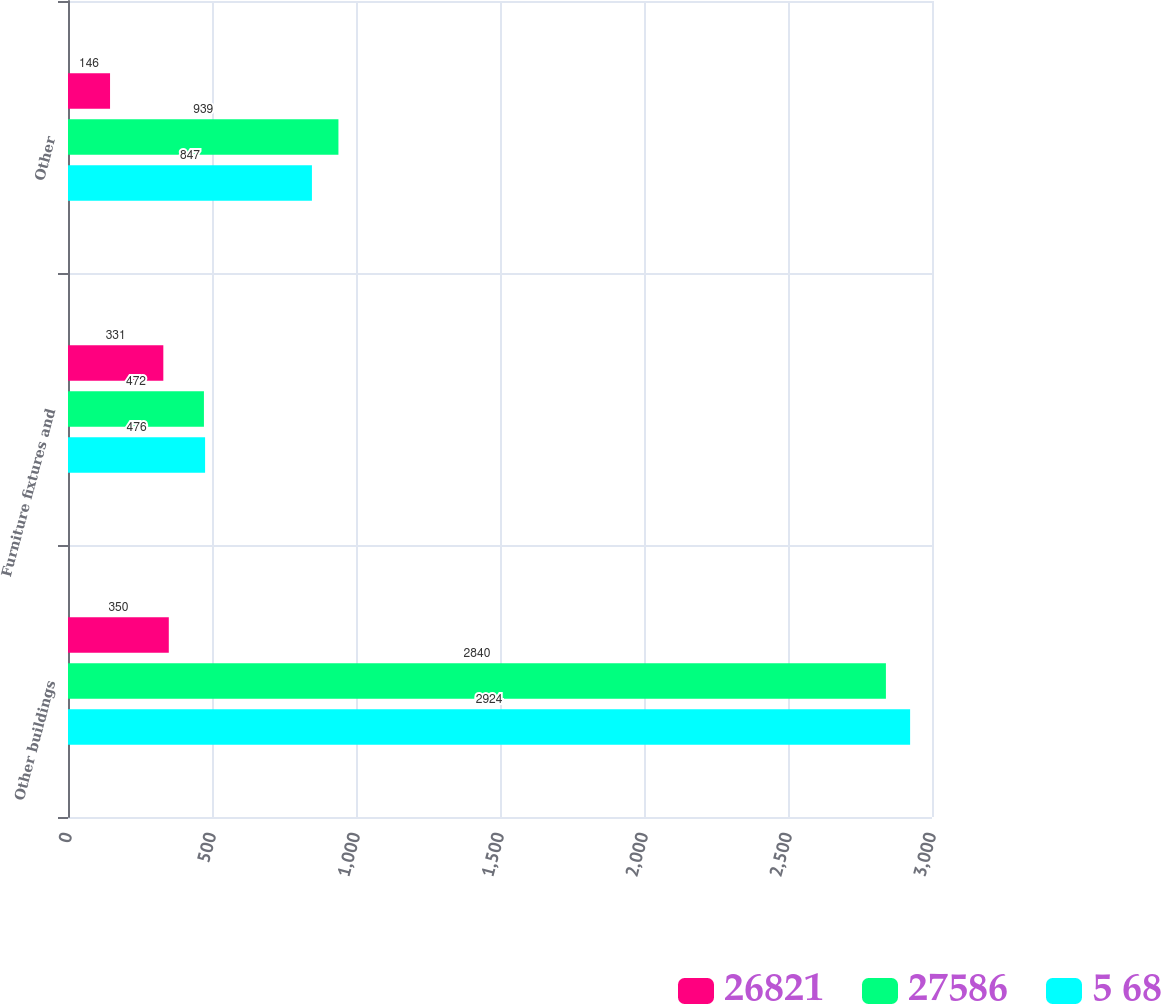Convert chart. <chart><loc_0><loc_0><loc_500><loc_500><stacked_bar_chart><ecel><fcel>Other buildings<fcel>Furniture fixtures and<fcel>Other<nl><fcel>26821<fcel>350<fcel>331<fcel>146<nl><fcel>27586<fcel>2840<fcel>472<fcel>939<nl><fcel>5 68<fcel>2924<fcel>476<fcel>847<nl></chart> 